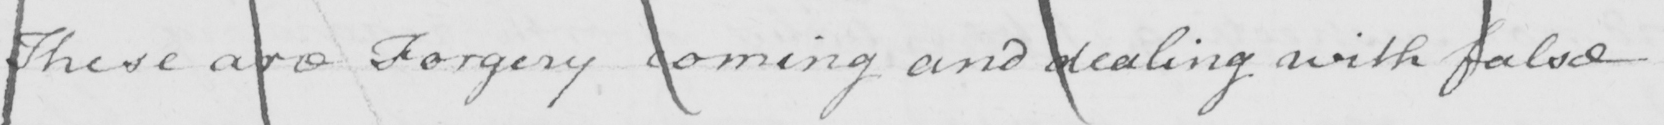Can you read and transcribe this handwriting? These are Forgery coining and dealing with false 